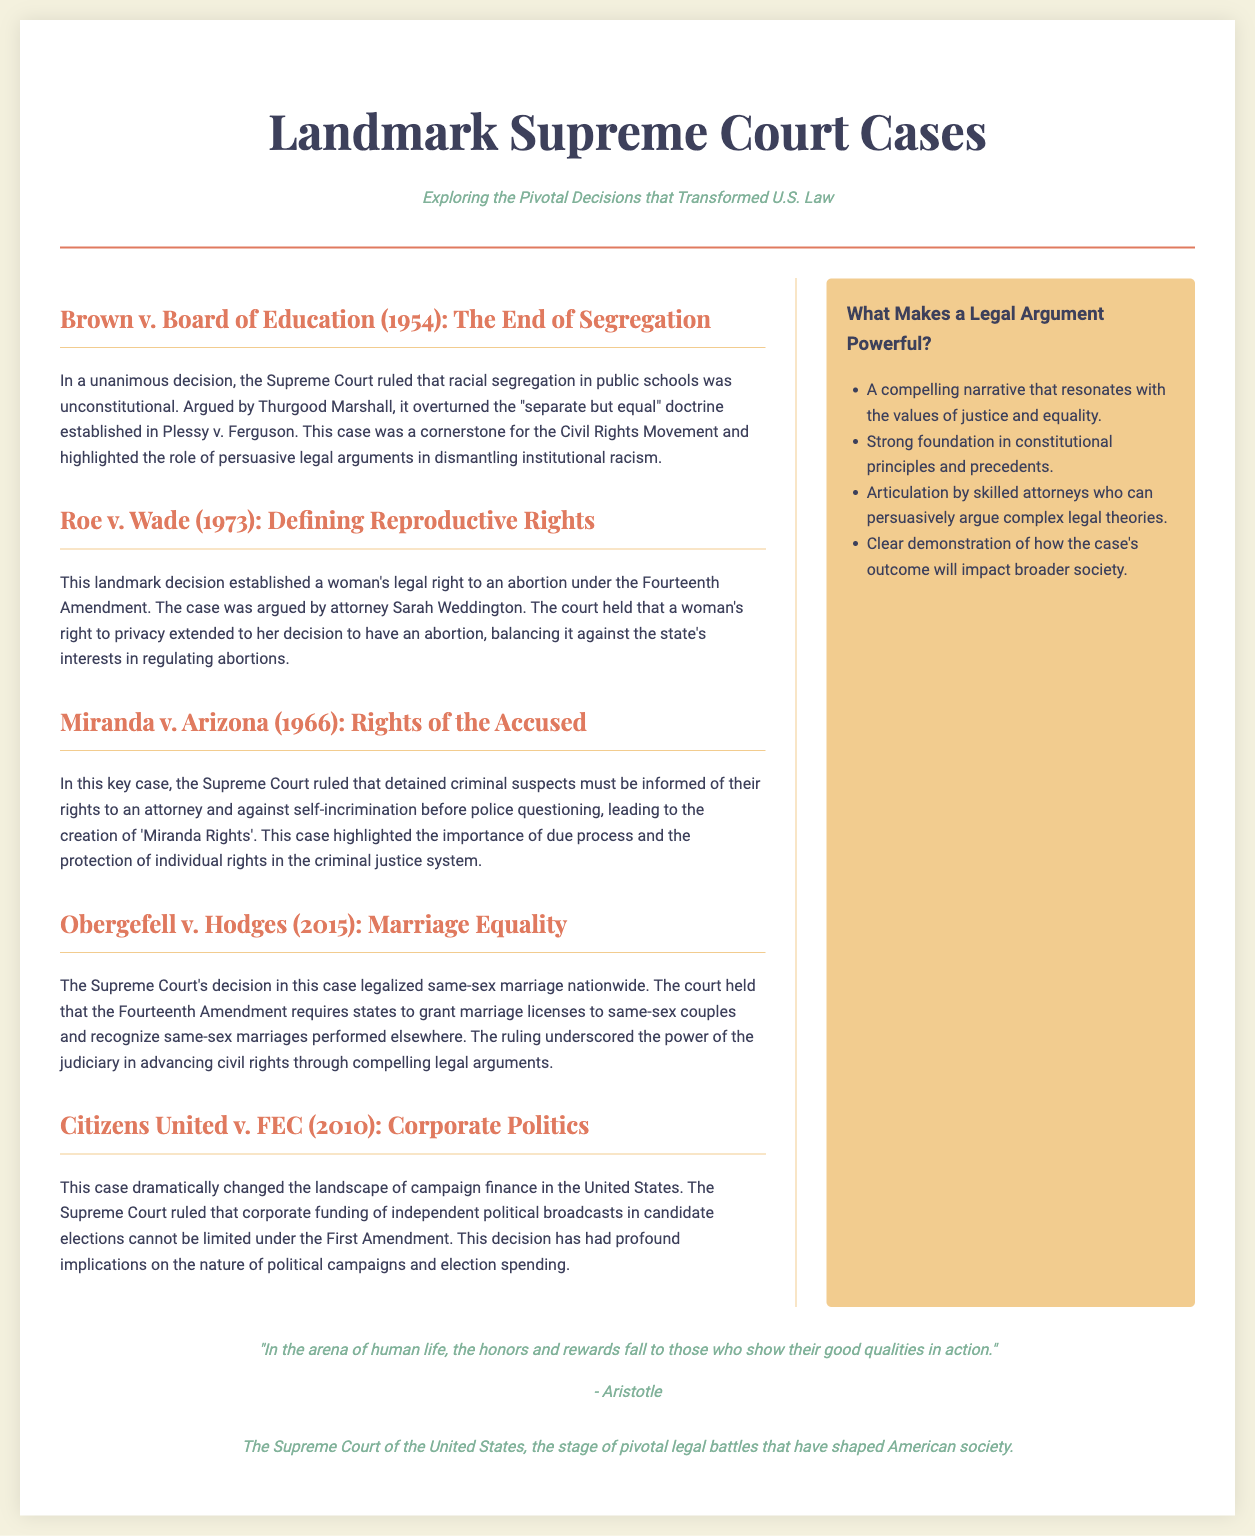What is the title of the document? The title is presented prominently at the top of the document and summarizes the content.
Answer: Landmark Supreme Court Cases Who argued Brown v. Board of Education? The document states the attorney who argued the case, highlighting key individuals involved in landmark decisions.
Answer: Thurgood Marshall What year was Roe v. Wade decided? The year of the decision is mentioned within the context of the case providing historical significance.
Answer: 1973 What amendment was referenced in Roe v. Wade? The specific amendment mentioned in connection with reproductive rights is essential to understanding the ruling.
Answer: Fourteenth Amendment What is one factor that makes a legal argument powerful? The sidebar lists elements that contribute to the effectiveness of legal arguments used in court cases.
Answer: A compelling narrative Which case legalized same-sex marriage nationwide? The document identifies significant Supreme Court decisions and their impacts on societal issues such as marriage equality.
Answer: Obergefell v. Hodges In what year was Citizens United v. FEC decided? The year of this pivotal case is provided in its description to understand its context in campaign finance.
Answer: 2010 What is the central theme of the quote by Aristotle? This quote is included to reflect on the value of action and qualities in the context of law and advocacy.
Answer: Action How many cases are discussed in the main content section? Counting the articles will reveal the number of landmark cases highlighted in the document.
Answer: Five What are the colors prominently featured in the newspaper layout? Identifying the color scheme can indicate design choices made for visual appeal and readability.
Answer: Soft beige, green, and dark blue 